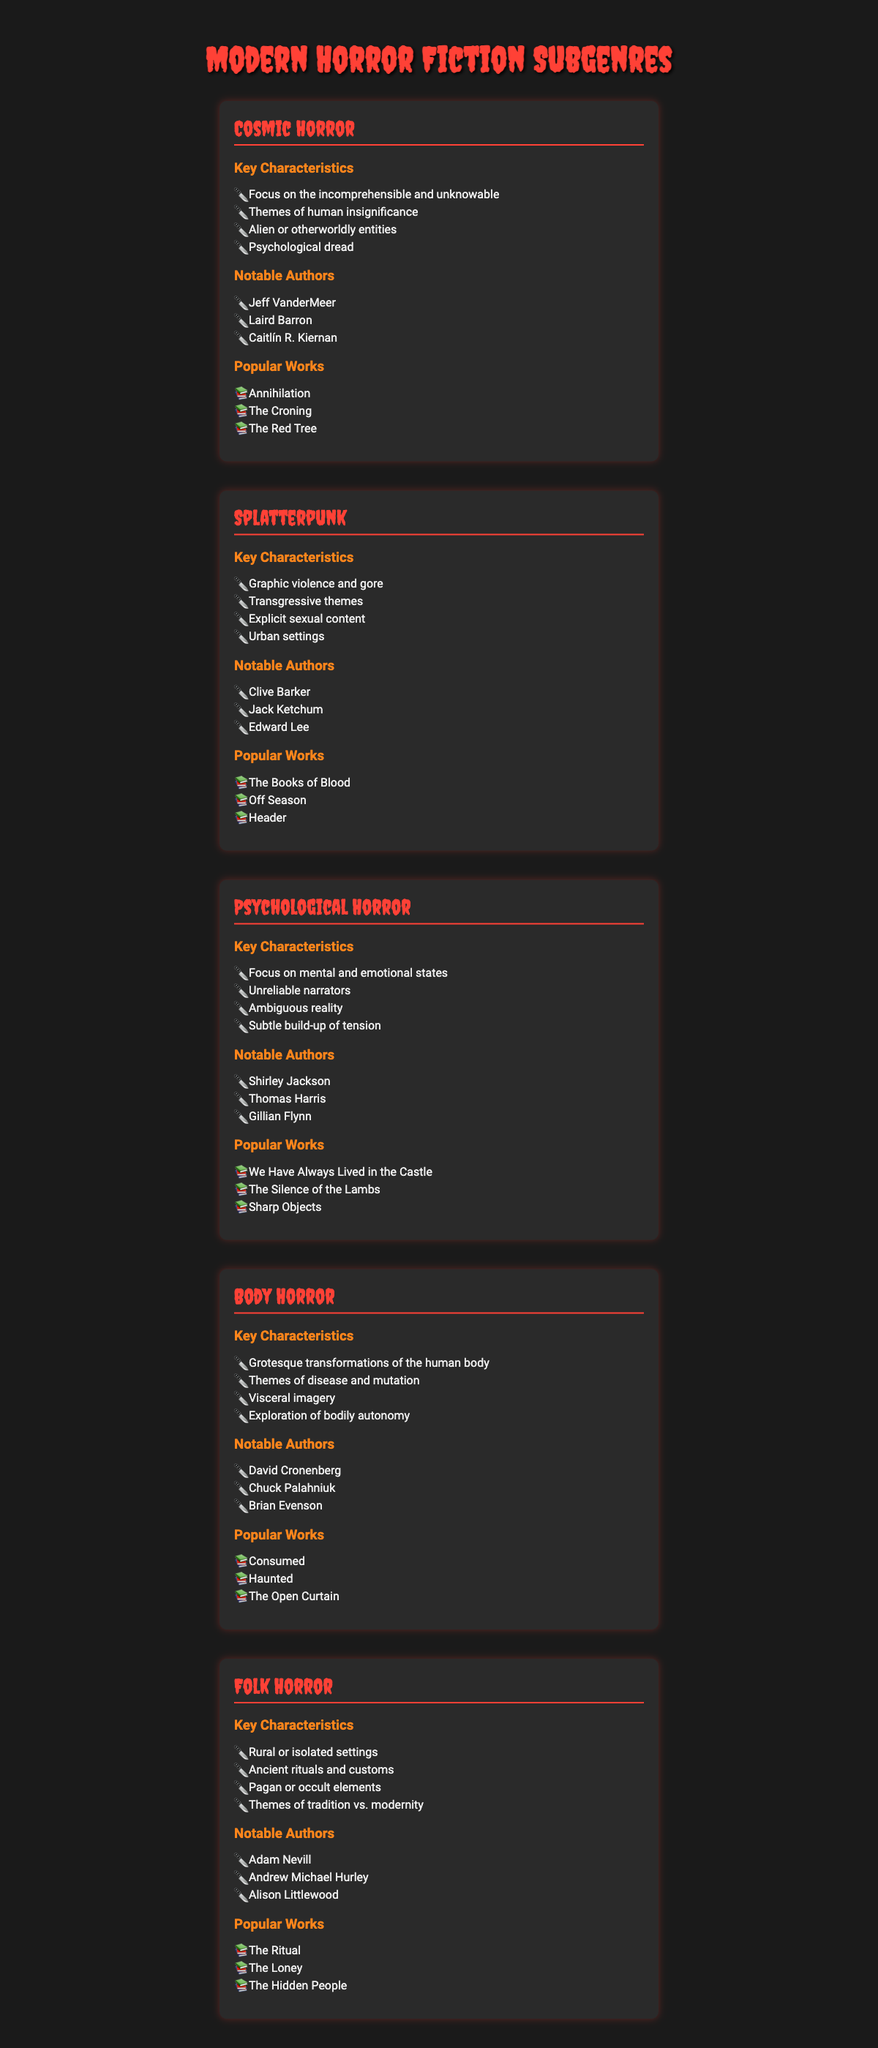What is a defining characteristic of Cosmic Horror? The table lists "Focus on the incomprehensible and unknowable" as one of the key characteristics of Cosmic Horror.
Answer: Focus on the incomprehensible and unknowable Which subgenre is noted for graphic violence and gore? The table indicates that the Splatterpunk subgenre is characterized by "Graphic violence and gore."
Answer: Splatterpunk Who is a notable author of Psychological Horror? According to the table, Shirley Jackson is listed as one of the notable authors of Psychological Horror.
Answer: Shirley Jackson How many subgenres are listed in the table? The table lists a total of five subgenres: Cosmic Horror, Splatterpunk, Psychological Horror, Body Horror, and Folk Horror.
Answer: Five subgenres Do Body Horror works usually include themes of bodily autonomy? The table states that Body Horror explores "themes of bodily autonomy," which confirms the fact.
Answer: Yes Which subgenre has notables like Jeff VanderMeer and Caitlín R. Kiernan? The table shows that Jeff VanderMeer and Caitlín R. Kiernan are notable authors of the Cosmic Horror subgenre.
Answer: Cosmic Horror Which subgenre combines themes of tradition vs. modernity? The table highlights that Folk Horror includes themes of "tradition vs. modernity" among its characteristics.
Answer: Folk Horror What are the key characteristics of Splatterpunk? The table details its key characteristics as "Graphic violence and gore, Transgressive themes, Explicit sexual content, Urban settings."
Answer: Four key characteristics Which subgenre shares authors with Cosmic Horror and Body Horror? The subgenre of Folk Horror shares common authors like Adam Nevill with Body Horror, hence overlapping in thematic exploration of horror.
Answer: No subgenre shares authors closely with both What is the average number of notable authors per subgenre? The total notable authors across subgenres is 12, divided among 5 subgenres resulting in an average of 12/5 = 2.4 notable authors per subgenre.
Answer: 2.4 notable authors 